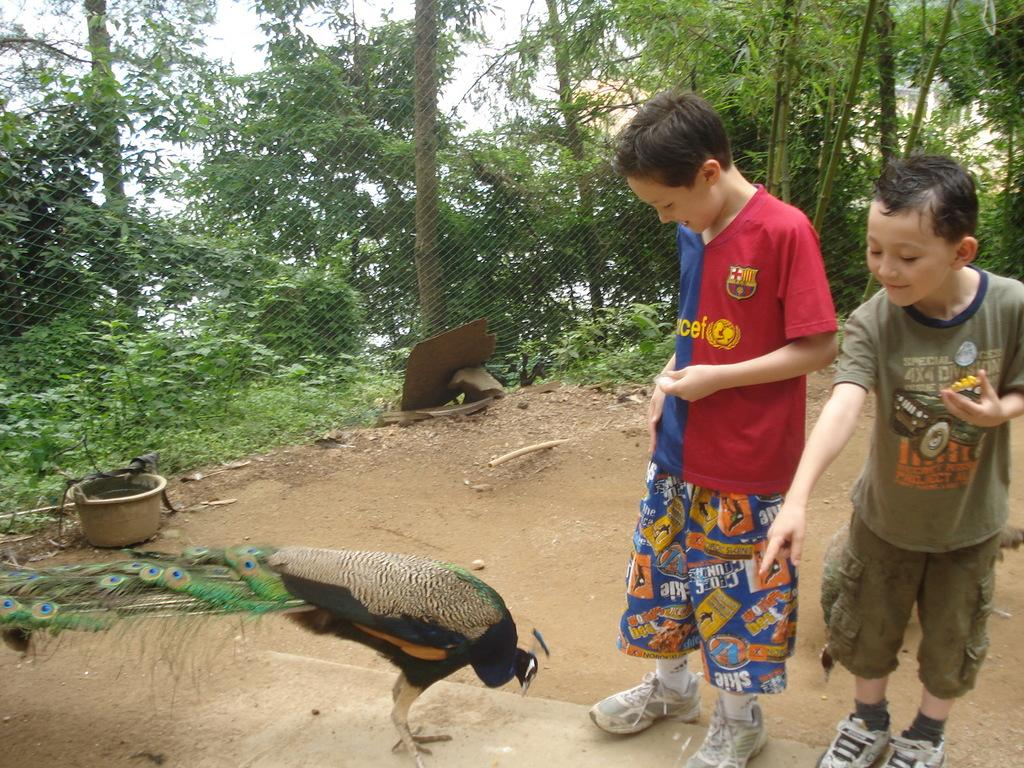How many people are in the image? There are two boys in the image. What animal is present in the image? There is a peacock in the image. What type of barrier can be seen in the image? There is an iron fence in the image. What type of vegetation is visible in the image? There are trees in the image. What is the condition of the sky in the image? The sky is clear in the image. Are there any fairies flying around the peacock in the image? There are no fairies present in the image. What type of operation is being performed on the trees in the image? There is no operation being performed on the trees in the image; they are simply standing there. 